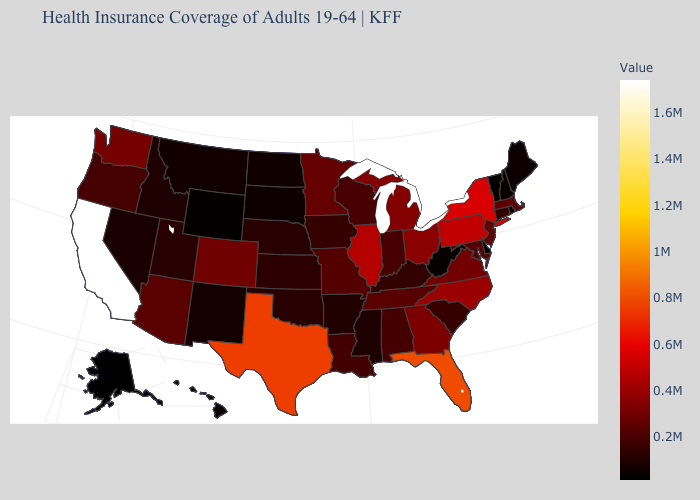Which states hav the highest value in the South?
Concise answer only. Florida. Among the states that border Georgia , which have the highest value?
Give a very brief answer. Florida. Which states have the lowest value in the MidWest?
Short answer required. South Dakota. Which states have the lowest value in the USA?
Concise answer only. Alaska. 